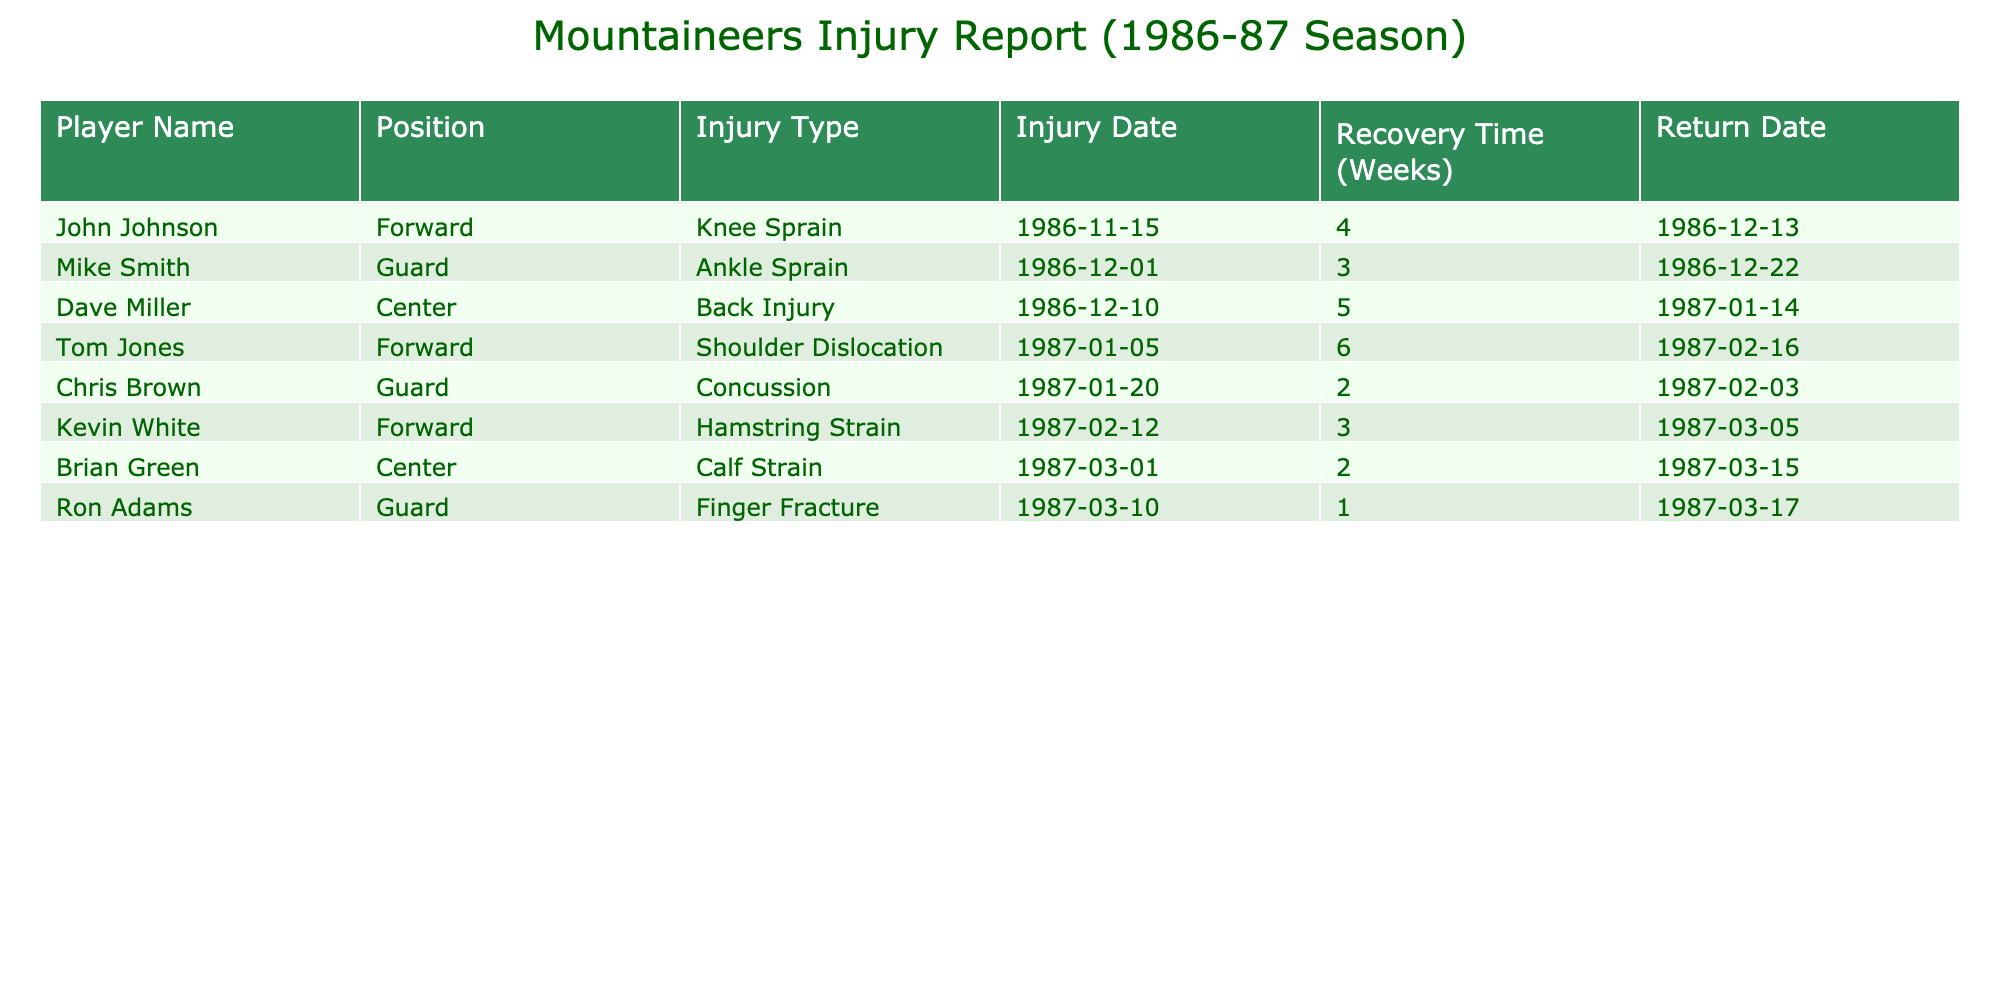What was the longest recovery time for a player? The longest recovery time listed in the table is 6 weeks, which applies to Tom Jones for his shoulder dislocation injury.
Answer: 6 weeks How many players returned from injuries in February 1987? The players who returned in February 1987 are Tom Jones (returned on February 16) and Chris Brown (returned on February 3). Therefore, there are 2 players who returned in February 1987.
Answer: 2 Did any players sustain injuries in December? Yes, two players sustained injuries in December: Mike Smith on December 1 and Dave Miller on December 10.
Answer: Yes What is the total recovery time for all players listed in the table? The recovery times are: John Johnson (4), Mike Smith (3), Dave Miller (5), Tom Jones (6), Chris Brown (2), Kevin White (3), Brian Green (2), Ron Adams (1). Adding these together gives 4 + 3 + 5 + 6 + 2 + 3 + 2 + 1 = 26 weeks in total.
Answer: 26 weeks Which player had an injury that caused them to return on the earliest date? The earliest return date is March 17 for Ron Adams, who had a finger fracture.
Answer: Ron Adams 